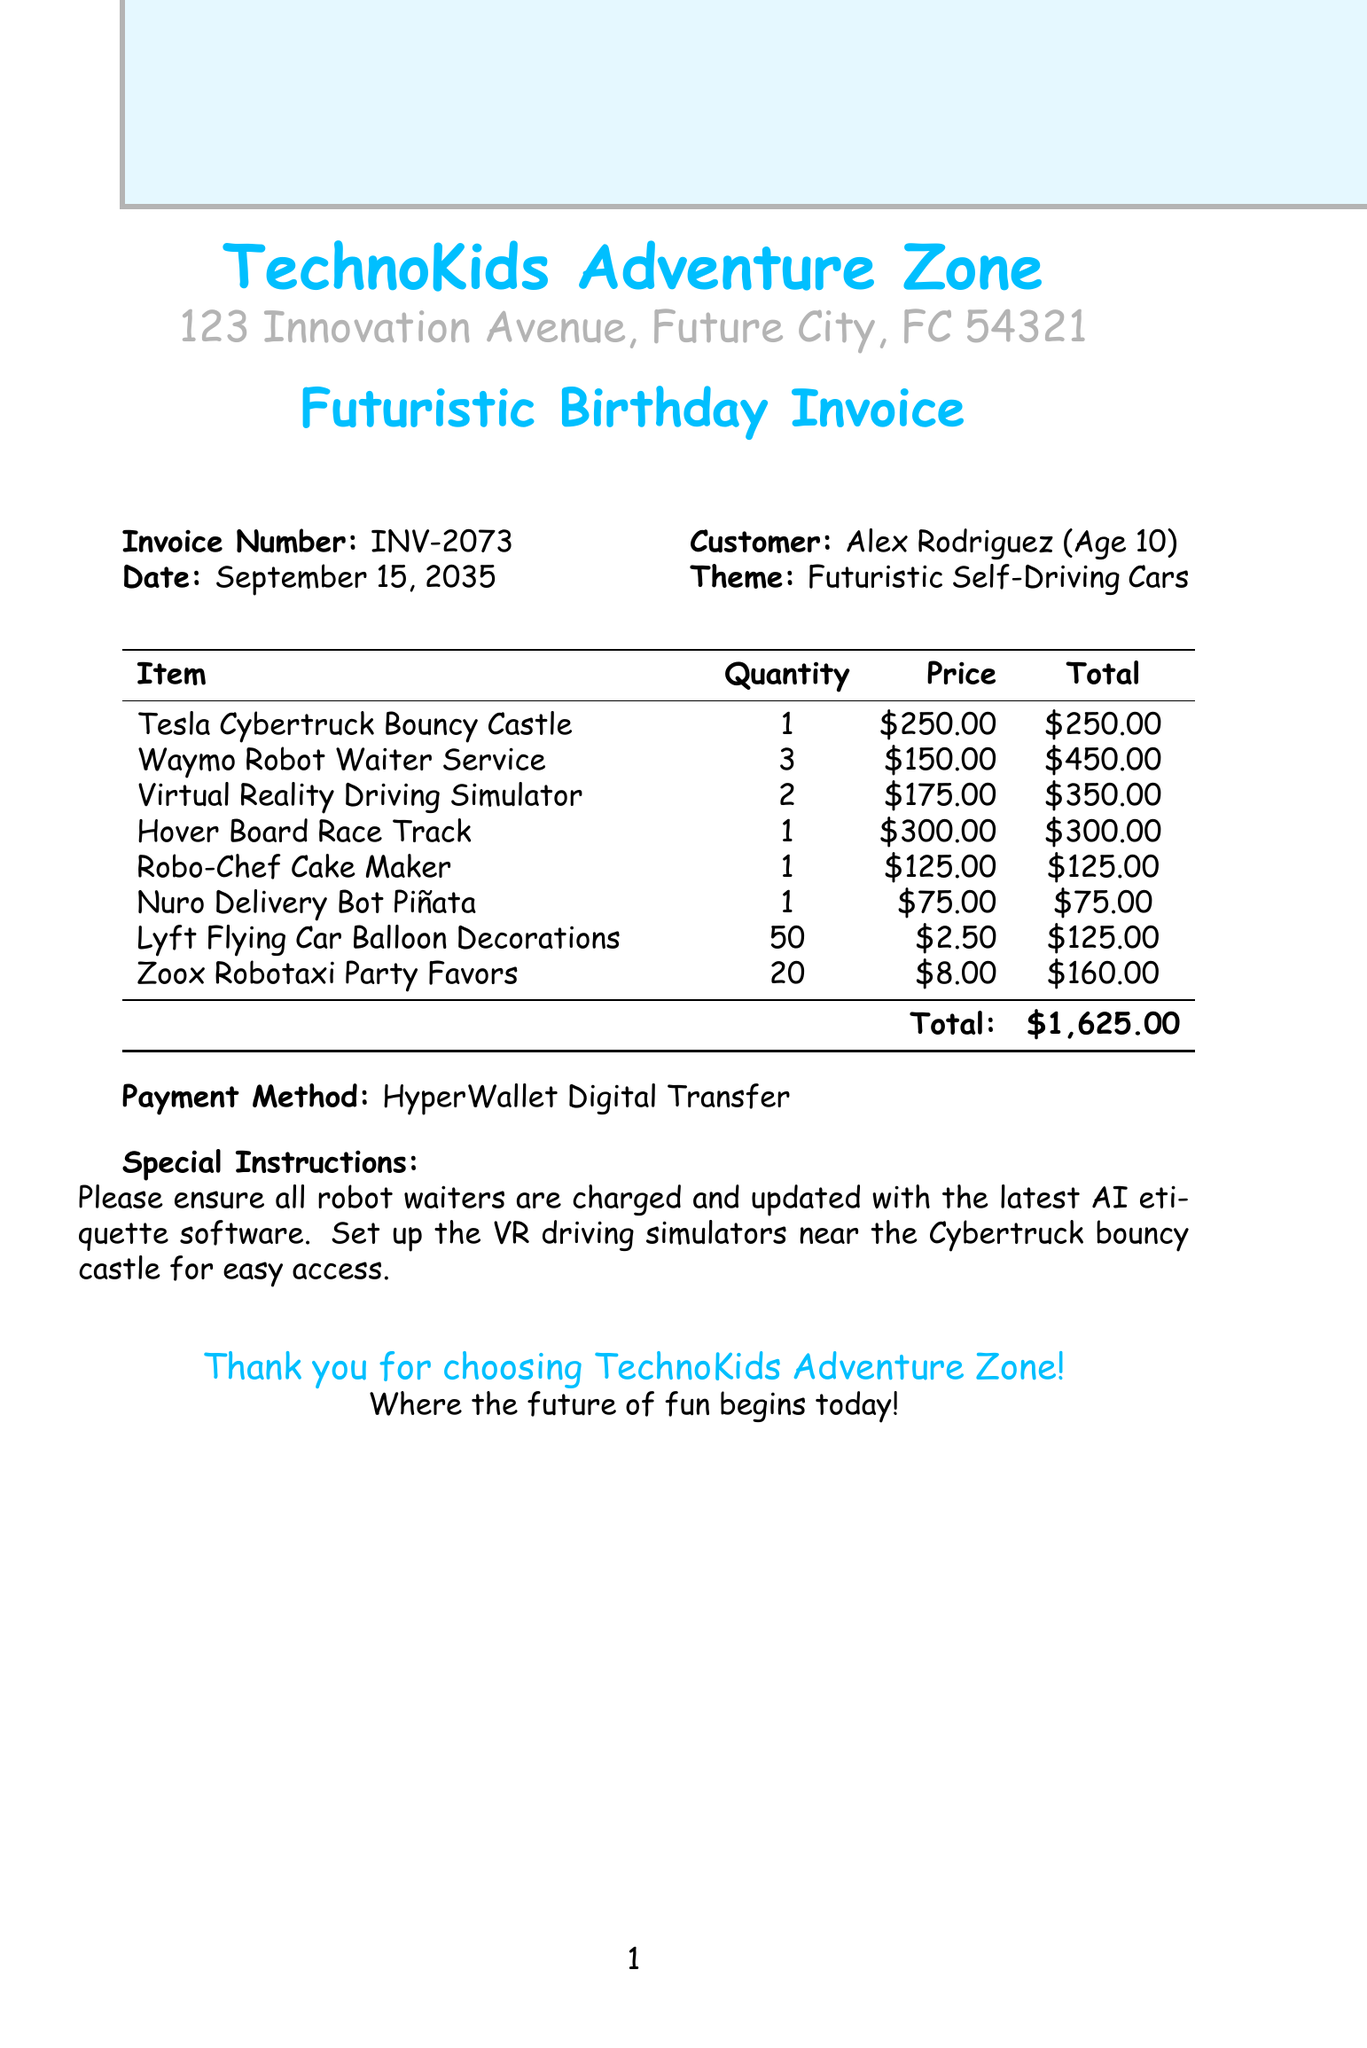What is the invoice number? The invoice number is listed prominently at the top of the invoice.
Answer: INV-2073 When was the birthday party held? The date of the invoice indicates when the birthday party was held.
Answer: September 15, 2035 What theme was chosen for the birthday party? The theme is mentioned in the document under "Theme."
Answer: Futuristic Self-Driving Cars How many Tesla Cybertruck Bouncy Castles were rented? The quantity for the Tesla Cybertruck Bouncy Castle is specified directly in the item list.
Answer: 1 What is the total amount due for the invoice? The total is calculated by summing up the costs of all items listed in the invoice.
Answer: $1,625.00 What payment method was used for the invoice? The payment method is clearly stated at the bottom of the invoice.
Answer: HyperWallet Digital Transfer How many robot waiters were included in the package? The number of robot waiters is indicated in the item description for the Waymo Robot Waiter Service.
Answer: 3 What special instruction was given regarding the robot waiters? Special instructions outline specific requirements for the robot waiters' setup.
Answer: Update with the latest AI etiquette software What kind of decorations were used for the party? The type of decorations is mentioned in the item list.
Answer: Lyft Flying Car Balloon Decorations 